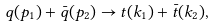Convert formula to latex. <formula><loc_0><loc_0><loc_500><loc_500>q ( p _ { 1 } ) + { \bar { q } } ( p _ { 2 } ) \rightarrow t ( k _ { 1 } ) + { \bar { t } } ( k _ { 2 } ) ,</formula> 